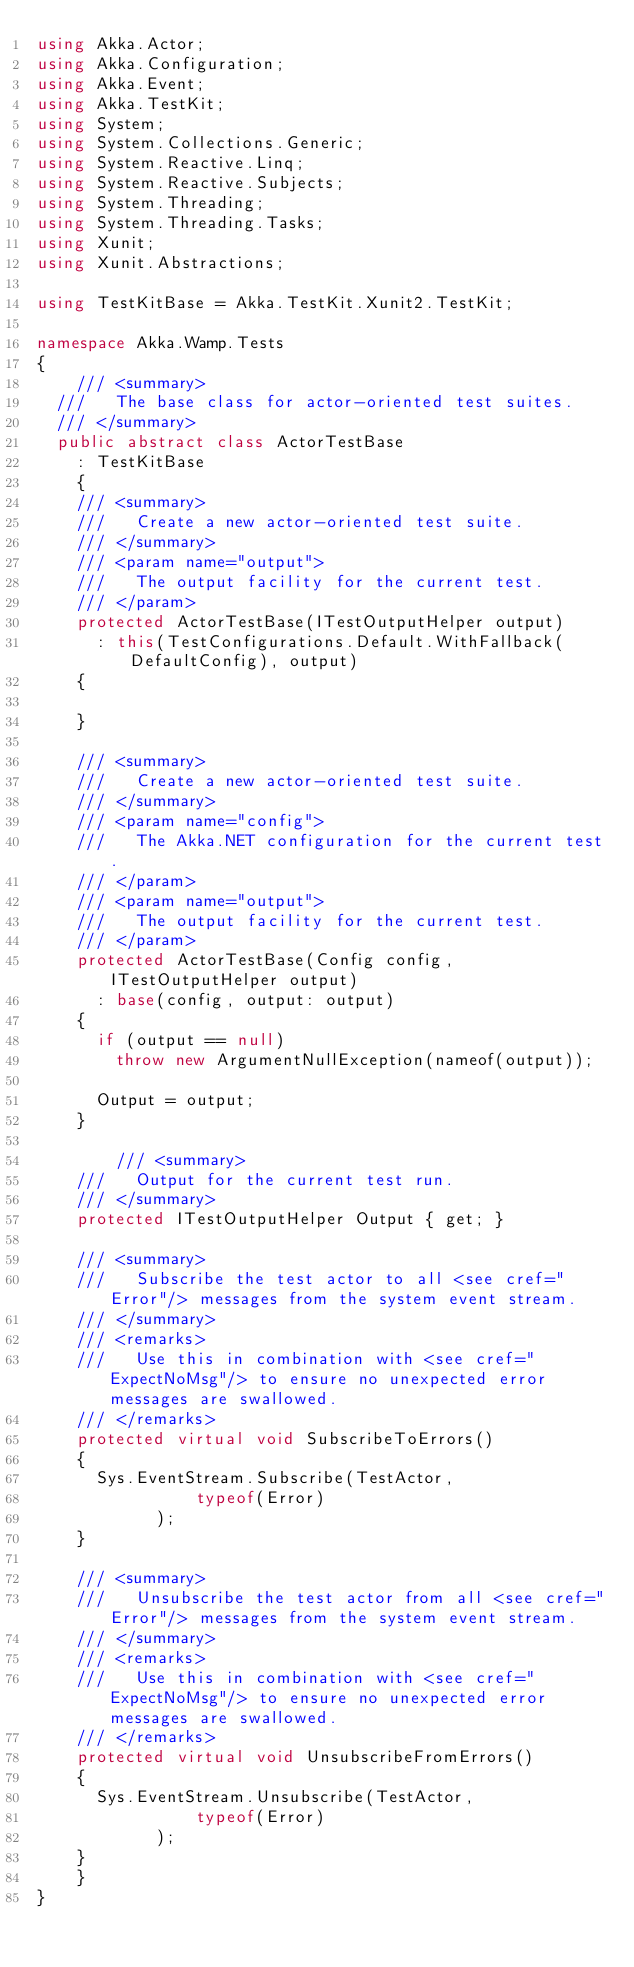Convert code to text. <code><loc_0><loc_0><loc_500><loc_500><_C#_>using Akka.Actor;
using Akka.Configuration;
using Akka.Event;
using Akka.TestKit;
using System;
using System.Collections.Generic;
using System.Reactive.Linq;
using System.Reactive.Subjects;
using System.Threading;
using System.Threading.Tasks;
using Xunit;
using Xunit.Abstractions;

using TestKitBase = Akka.TestKit.Xunit2.TestKit;

namespace Akka.Wamp.Tests
{
    /// <summary>
	///		The base class for actor-oriented test suites.
	/// </summary>
	public abstract class ActorTestBase
		: TestKitBase
    {
		/// <summary>
		/// 	Create a new actor-oriented test suite.
		/// </summary>
		/// <param name="output">
		/// 	The output facility for the current test.
		/// </param>
		protected ActorTestBase(ITestOutputHelper output)
			: this(TestConfigurations.Default.WithFallback(DefaultConfig), output)
		{

		}
		
		/// <summary>
		/// 	Create a new actor-oriented test suite.
		/// </summary>
		/// <param name="config">
		/// 	The Akka.NET configuration for the current test.
		/// </param>
		/// <param name="output">
		/// 	The output facility for the current test.
		/// </param>
		protected ActorTestBase(Config config, ITestOutputHelper output)
			: base(config, output: output)
		{
			if (output == null)
				throw new ArgumentNullException(nameof(output));
			
			Output = output;
		}

        /// <summary>
		///		Output for the current test run.
		/// </summary>
		protected ITestOutputHelper Output { get; }

		/// <summary>
		/// 	Subscribe the test actor to all <see cref="Error"/> messages from the system event stream.
		/// </summary>
		/// <remarks>
		/// 	Use this in combination with <see cref="ExpectNoMsg"/> to ensure no unexpected error messages are swallowed.
		/// </remarks>
		protected virtual void SubscribeToErrors()
		{
			Sys.EventStream.Subscribe(TestActor,
                typeof(Error)
            );
		}

		/// <summary>
		/// 	Unsubscribe the test actor from all <see cref="Error"/> messages from the system event stream.
		/// </summary>
		/// <remarks>
		/// 	Use this in combination with <see cref="ExpectNoMsg"/> to ensure no unexpected error messages are swallowed.
		/// </remarks>
		protected virtual void UnsubscribeFromErrors()
		{
			Sys.EventStream.Unsubscribe(TestActor,
                typeof(Error)
            );
		}
    }
}
</code> 